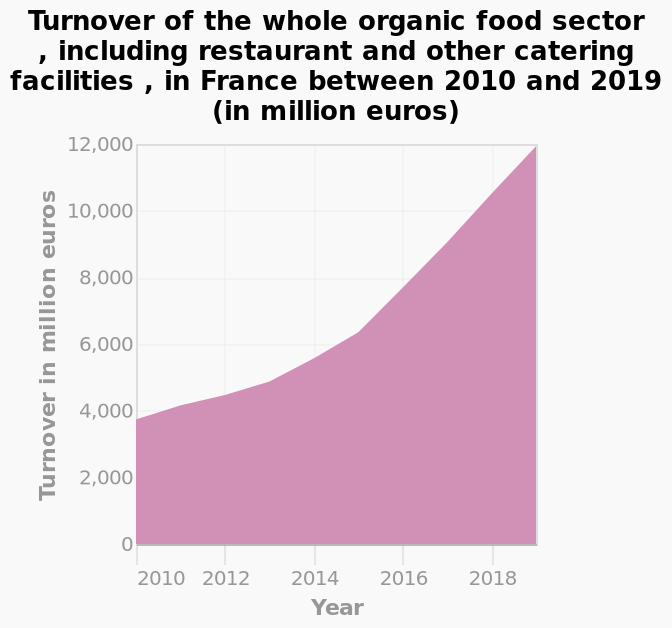<image>
What is the title of the graph?  The title of the graph is "Turnover of the whole organic food sector, including restaurant and other catering facilities, in France between 2010 and 2019 (in million euros)." please summary the statistics and relations of the chart The turnover increased year on year during this period from about 4,000 to 12,000 by the end of 2018. This increase was fairly linear  for the years of 2010-2012 then became more parabolic from 2012 to 2019, looking fairly parabolic. 